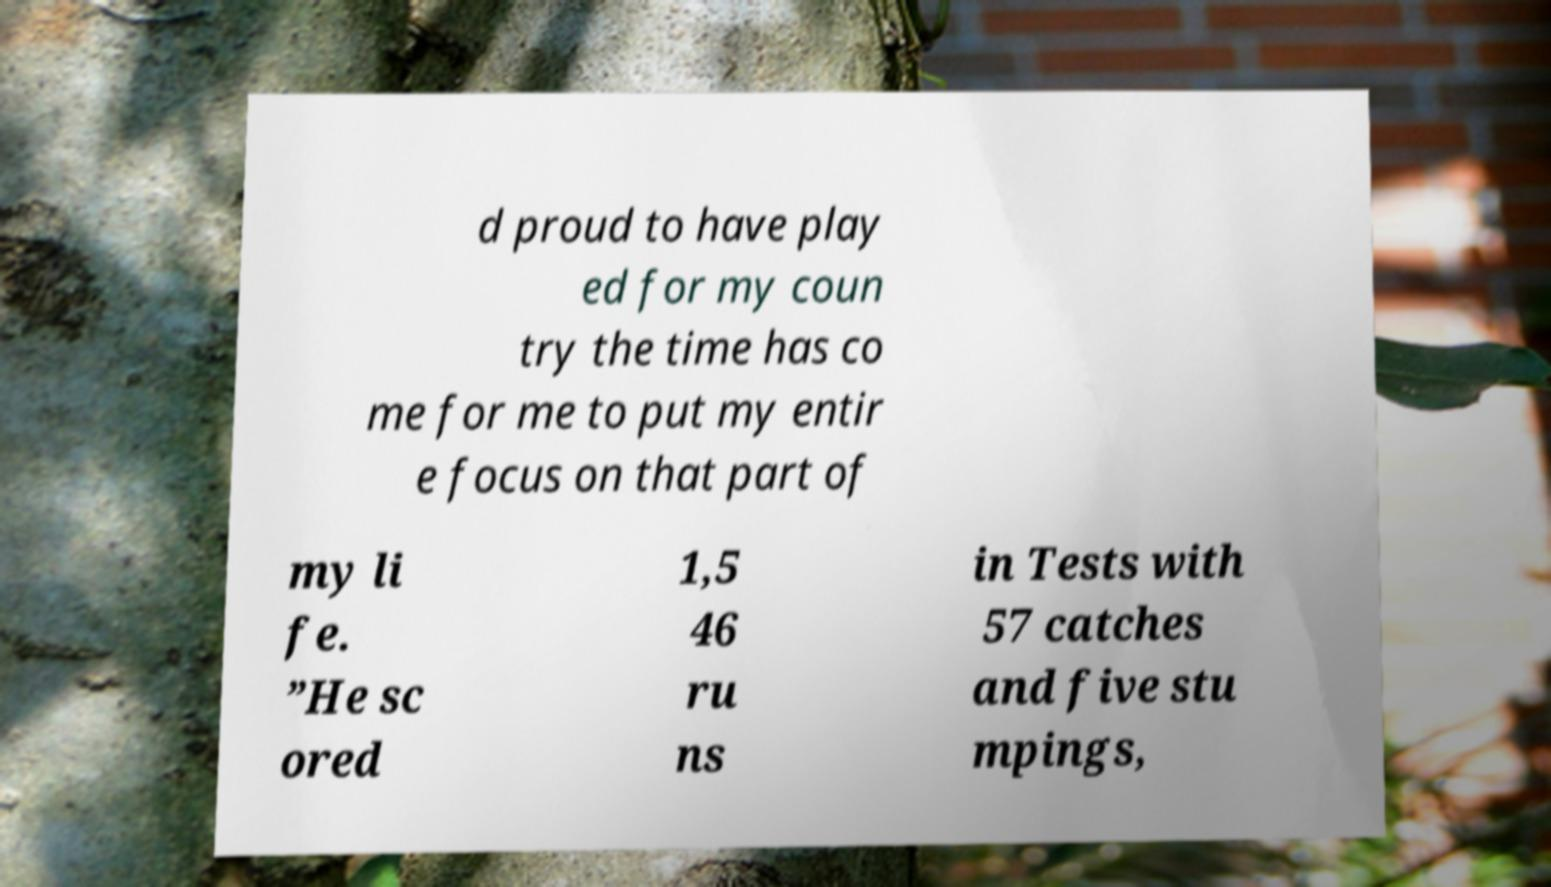What messages or text are displayed in this image? I need them in a readable, typed format. d proud to have play ed for my coun try the time has co me for me to put my entir e focus on that part of my li fe. ”He sc ored 1,5 46 ru ns in Tests with 57 catches and five stu mpings, 